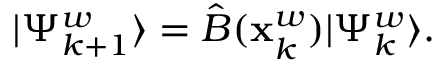<formula> <loc_0><loc_0><loc_500><loc_500>\begin{array} { r } { | \Psi _ { k + 1 } ^ { w } \rangle = \hat { B } ( \mathbf x _ { k } ^ { w } ) | \Psi _ { k } ^ { w } \rangle . } \end{array}</formula> 